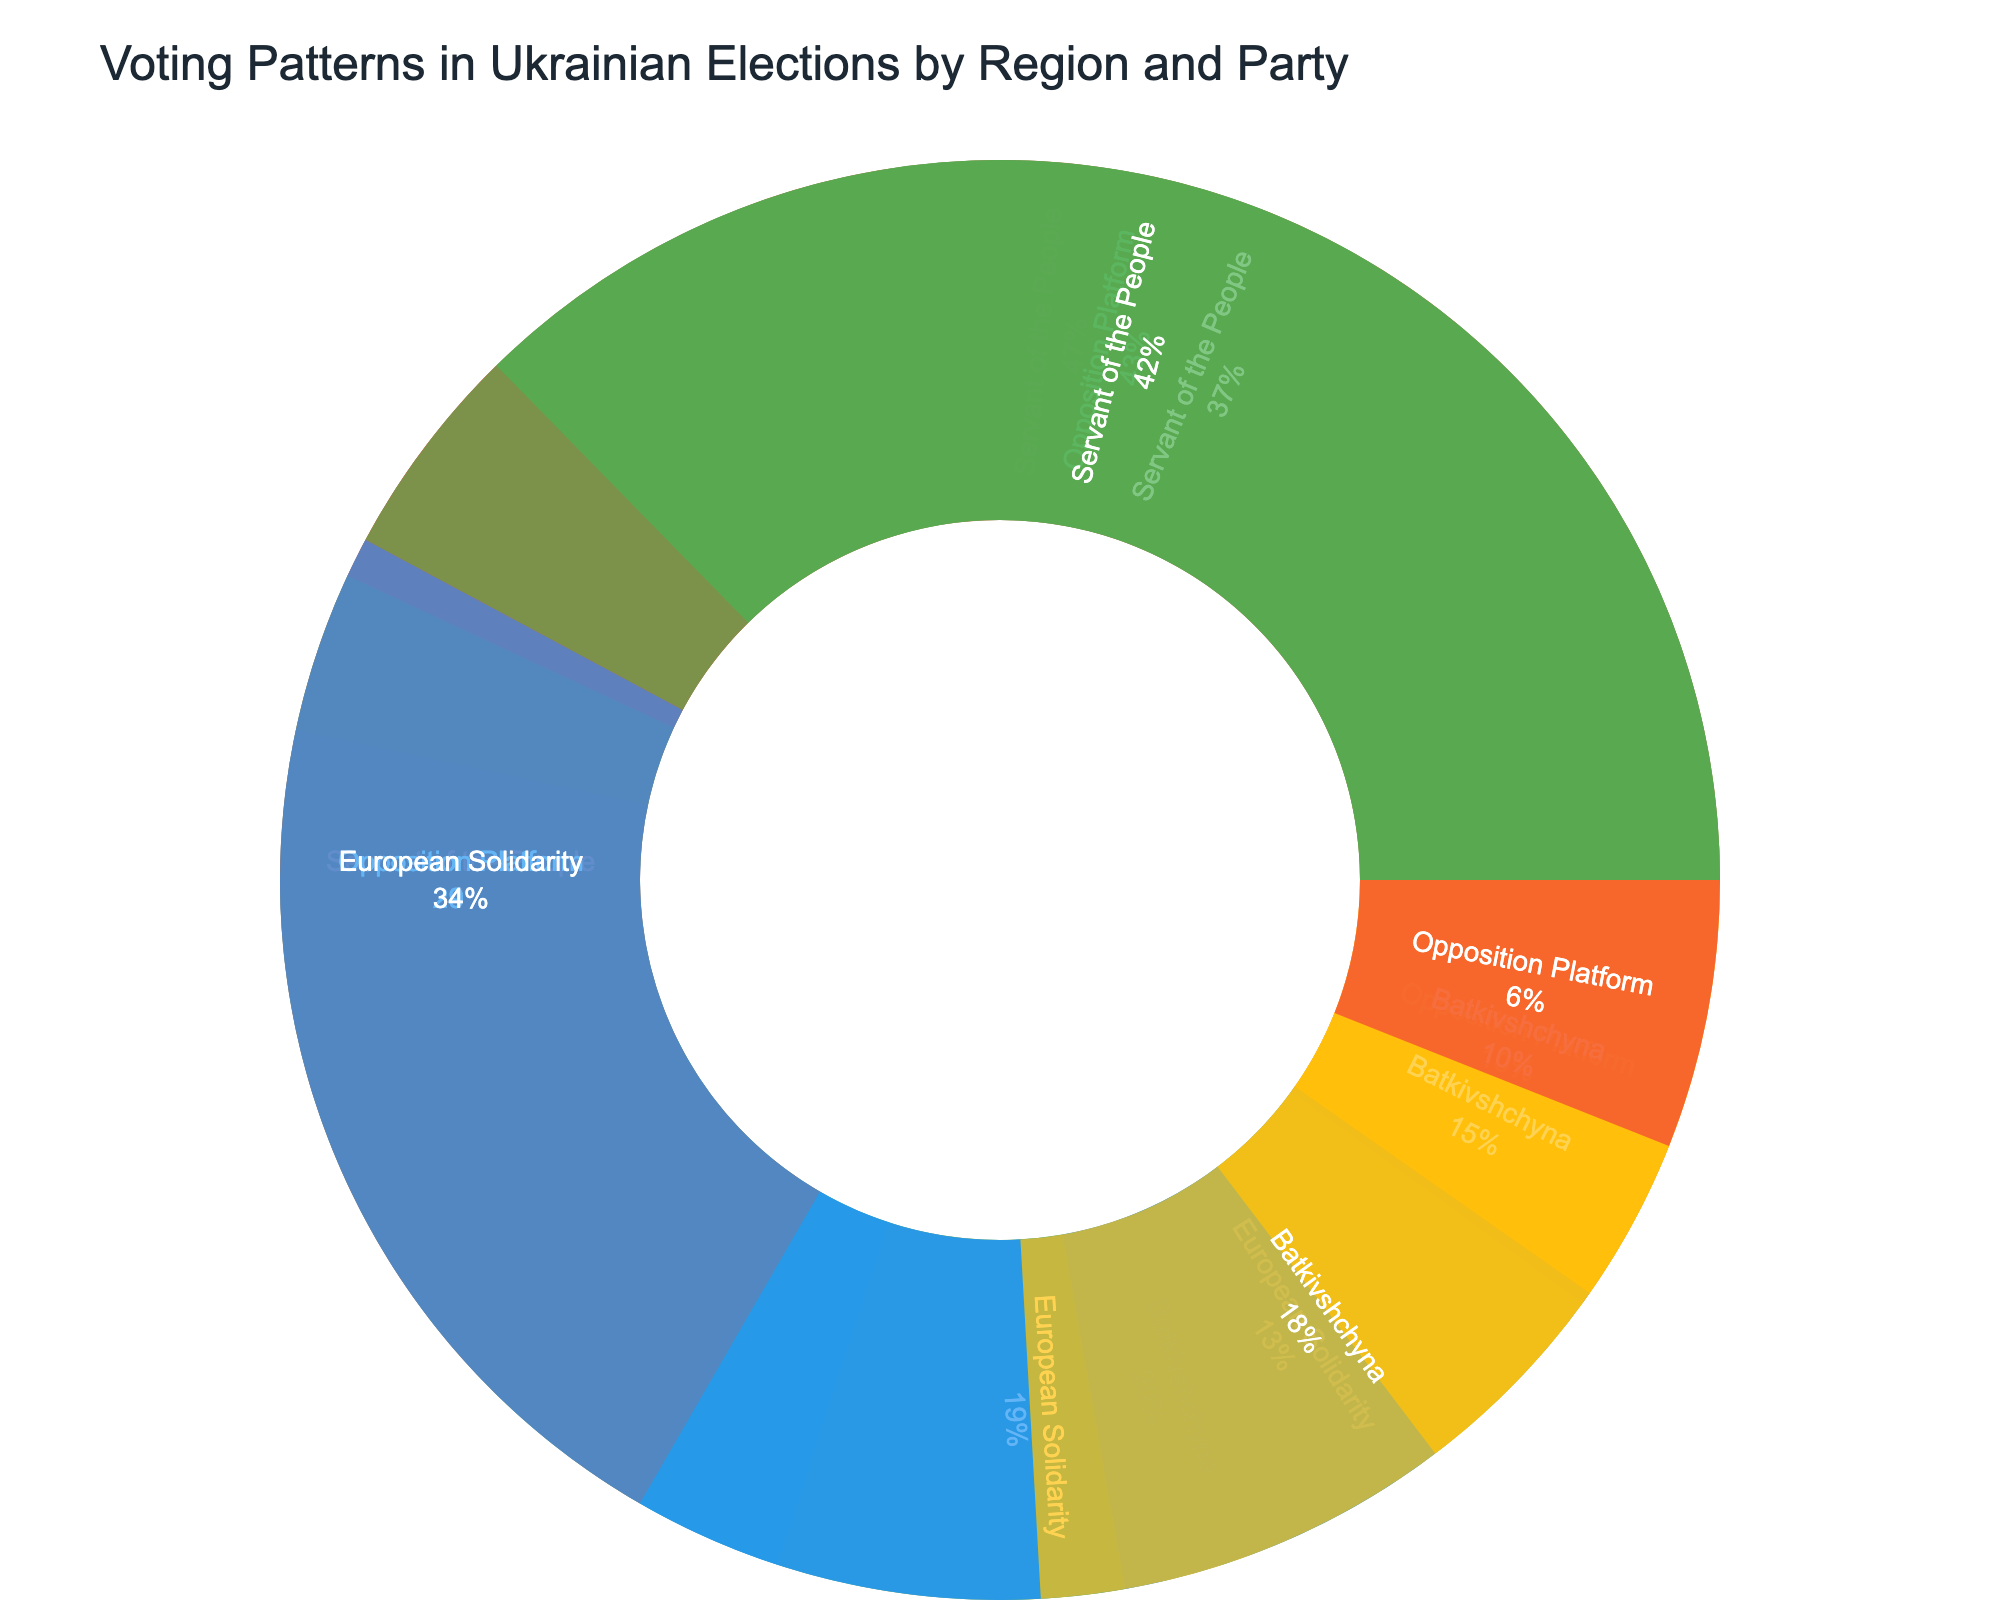What is the most popular party in Western Ukraine? The most popular party in Western Ukraine is determined by the largest segment in the Western Ukraine region of the sunburst chart. A larger segment indicates a higher number of votes.
Answer: Servant of the People Which region has the highest number of votes for the Opposition Platform? To identify the region with the highest number of votes for the Opposition Platform, compare the sizes of the segments labeled "Opposition Platform" across all regions in the sunburst chart. The largest segment indicates the highest number of votes.
Answer: Eastern Ukraine How do the votes for Batkivshchyna in Southern Ukraine compare to those in Central Ukraine? To compare the votes for Batkivshchyna in Southern Ukraine and Central Ukraine, examine the sizes of the segments labeled "Batkivshchyna" in both regions in the chart. Note the relative sizes or check the percentages if displayed.
Answer: Central Ukraine has more votes for Batkivshchyna What is the total percentage of votes received by Servant of the People across all regions? Sum the percentages of votes received by Servant of the People in each region (Western Ukraine, Central Ukraine, Southern Ukraine, Eastern Ukraine). Since the plot shows individual percentages within regions, add them up.
Answer: 41% (approximate, by totaling the percentages of each segment) Which party received the least votes in Western Ukraine? The party with the smallest segment within the Western Ukraine part of the sunburst chart received the least votes.
Answer: Opposition Platform What's the difference in votes for European Solidarity between Central and Eastern Ukraine? Subtract the number of votes for European Solidarity in Eastern Ukraine from those in Central Ukraine. These values can be found in the labels and segments' size in the chart.
Answer: 1,200,000 Are there any regions where Servant of the People received less than 30% of the votes? For each region, check the percentage displayed for Servant of the People. If any of these percentages are below 30%, that region meets the criteria.
Answer: No What is the percentage of votes received by Batkivshchyna in Western Ukraine? Look at the segment labelled "Batkivshchyna" within the Western Ukraine region. The percentage value should be displayed directly on or near the segment.
Answer: 18% In which region does the European Solidarity have the highest percentage of votes? Compare the percentages for European Solidarity across all regions. The region with the highest percentage displayed in its segment represents the highest proportion of votes.
Answer: Western Ukraine What is the combined vote percentage of European Solidarity and Batkivshchyna in Eastern Ukraine? Add the individual percentages of European Solidarity and Batkivshchyna in the Eastern Ukraine region. The percentages are shown within the sunburst chart segments.
Answer: 20% 